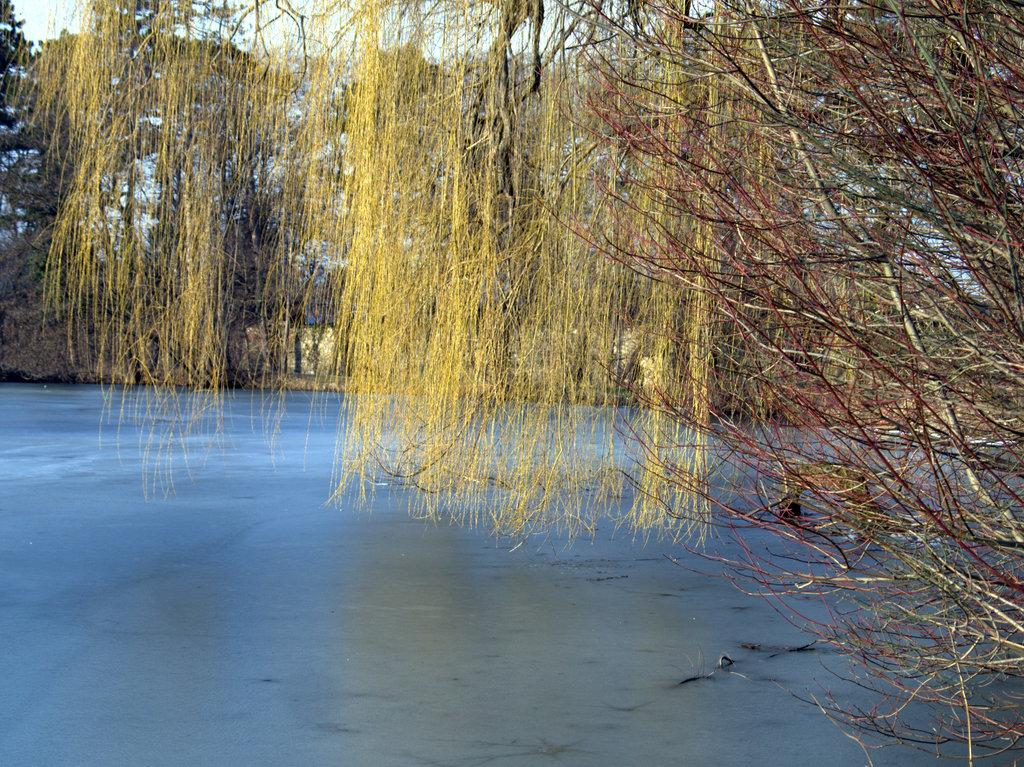What type of vegetation can be seen in the image? There are trees in the image. What natural element is visible besides the trees? There is water visible in the image. What can be seen in the background of the image? The sky is visible in the background of the image. How many beds can be seen in the image? There are no beds present in the image. What type of leaf is on the tree in the image? There is no specific leaf mentioned or visible in the image; only trees are mentioned. 